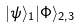<formula> <loc_0><loc_0><loc_500><loc_500>| \psi \rangle _ { 1 } | \Phi \rangle _ { 2 , 3 }</formula> 